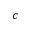<formula> <loc_0><loc_0><loc_500><loc_500>c</formula> 